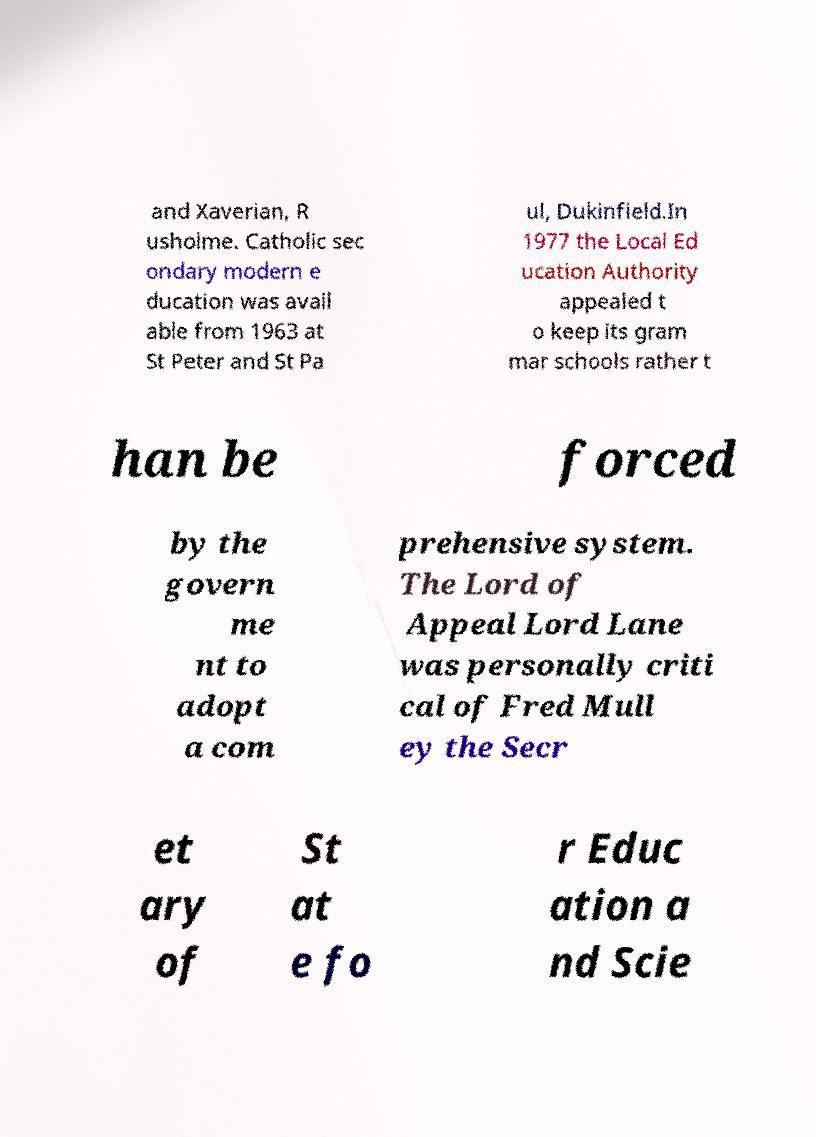Can you accurately transcribe the text from the provided image for me? and Xaverian, R usholme. Catholic sec ondary modern e ducation was avail able from 1963 at St Peter and St Pa ul, Dukinfield.In 1977 the Local Ed ucation Authority appealed t o keep its gram mar schools rather t han be forced by the govern me nt to adopt a com prehensive system. The Lord of Appeal Lord Lane was personally criti cal of Fred Mull ey the Secr et ary of St at e fo r Educ ation a nd Scie 